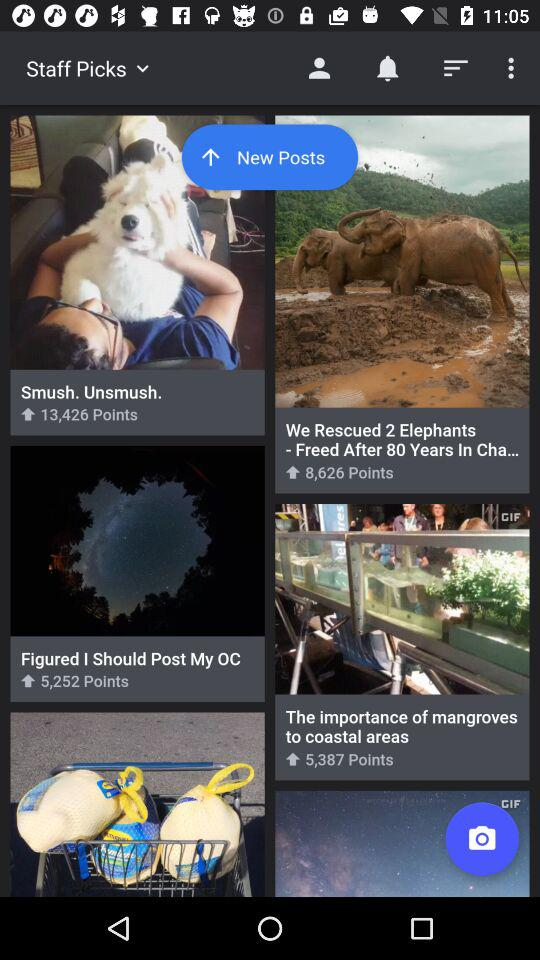How many points are shown for "The importance of mangroves to coastal areas"? The number of points is 5,387. 